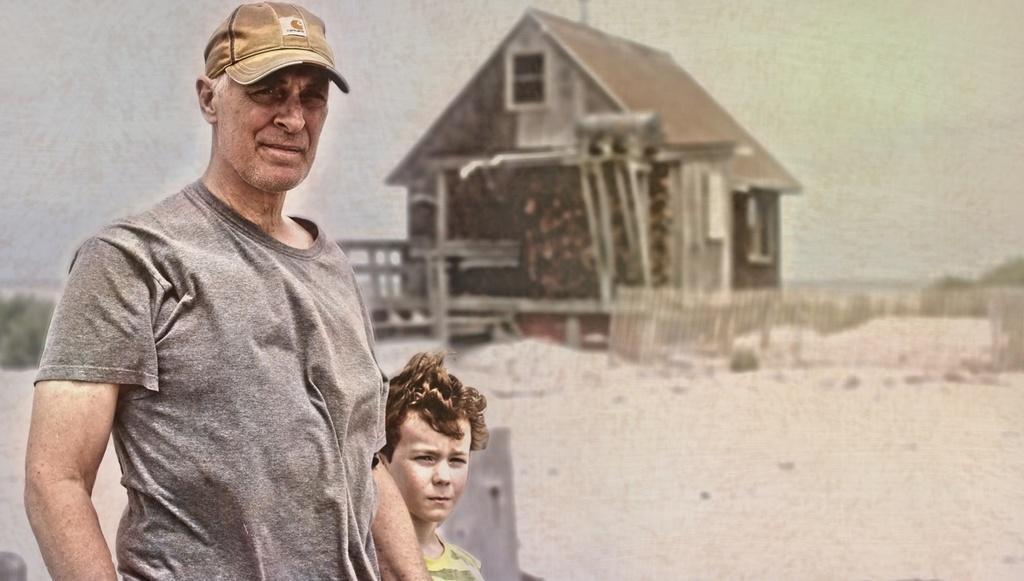Can you describe this image briefly? In this image we can see a man and a child standing. On the backside we can see the picture of a house, the wooden fence, some plants and the sky. 